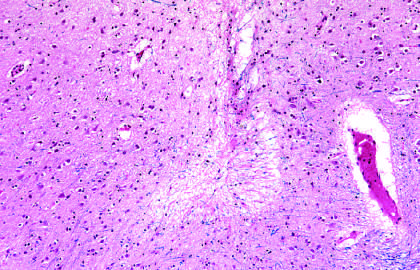when does an area of infarction show the presence of macrophages and surrounding reactive gliosis?
Answer the question using a single word or phrase. By day 10 